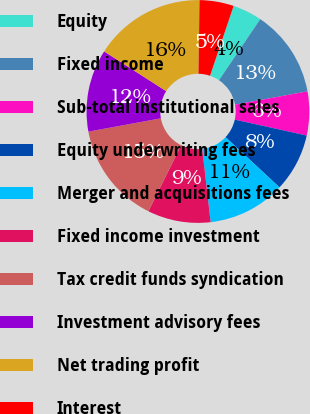Convert chart to OTSL. <chart><loc_0><loc_0><loc_500><loc_500><pie_chart><fcel>Equity<fcel>Fixed income<fcel>Sub-total institutional sales<fcel>Equity underwriting fees<fcel>Merger and acquisitions fees<fcel>Fixed income investment<fcel>Tax credit funds syndication<fcel>Investment advisory fees<fcel>Net trading profit<fcel>Interest<nl><fcel>4.26%<fcel>12.66%<fcel>6.36%<fcel>8.46%<fcel>11.26%<fcel>9.16%<fcel>14.76%<fcel>11.96%<fcel>16.16%<fcel>4.96%<nl></chart> 